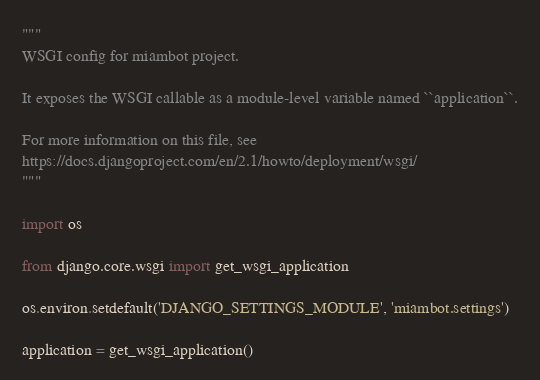<code> <loc_0><loc_0><loc_500><loc_500><_Python_>"""
WSGI config for miambot project.

It exposes the WSGI callable as a module-level variable named ``application``.

For more information on this file, see
https://docs.djangoproject.com/en/2.1/howto/deployment/wsgi/
"""

import os

from django.core.wsgi import get_wsgi_application

os.environ.setdefault('DJANGO_SETTINGS_MODULE', 'miambot.settings')

application = get_wsgi_application()
</code> 